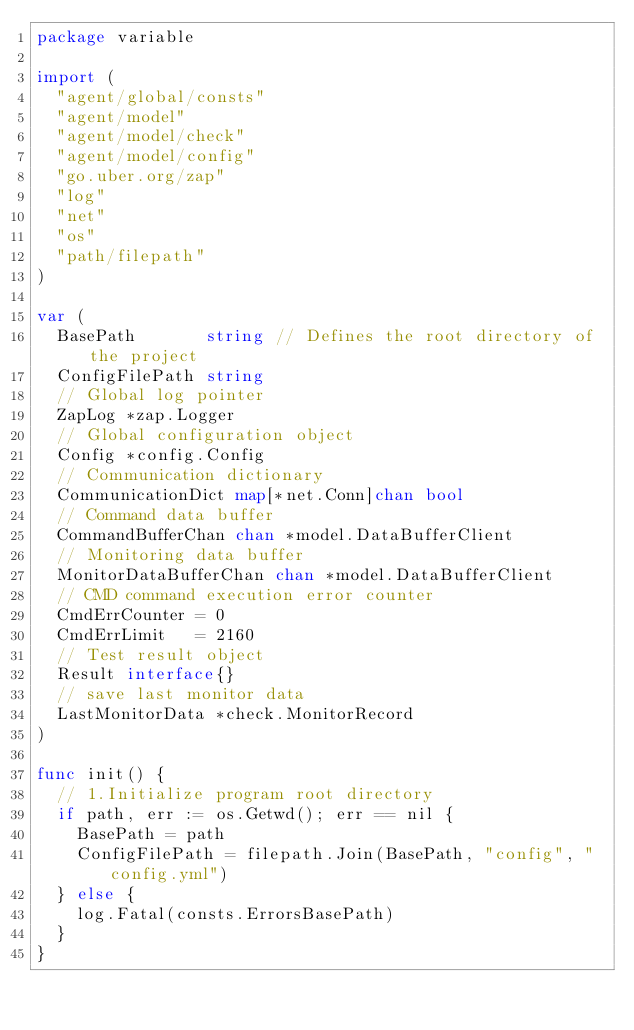Convert code to text. <code><loc_0><loc_0><loc_500><loc_500><_Go_>package variable

import (
	"agent/global/consts"
	"agent/model"
	"agent/model/check"
	"agent/model/config"
	"go.uber.org/zap"
	"log"
	"net"
	"os"
	"path/filepath"
)

var (
	BasePath       string // Defines the root directory of the project
	ConfigFilePath string
	// Global log pointer
	ZapLog *zap.Logger
	// Global configuration object
	Config *config.Config
	// Communication dictionary
	CommunicationDict map[*net.Conn]chan bool
	// Command data buffer
	CommandBufferChan chan *model.DataBufferClient
	// Monitoring data buffer
	MonitorDataBufferChan chan *model.DataBufferClient
	// CMD command execution error counter
	CmdErrCounter = 0
	CmdErrLimit   = 2160
	// Test result object
	Result interface{}
	// save last monitor data
	LastMonitorData *check.MonitorRecord
)

func init() {
	// 1.Initialize program root directory
	if path, err := os.Getwd(); err == nil {
		BasePath = path
		ConfigFilePath = filepath.Join(BasePath, "config", "config.yml")
	} else {
		log.Fatal(consts.ErrorsBasePath)
	}
}
</code> 